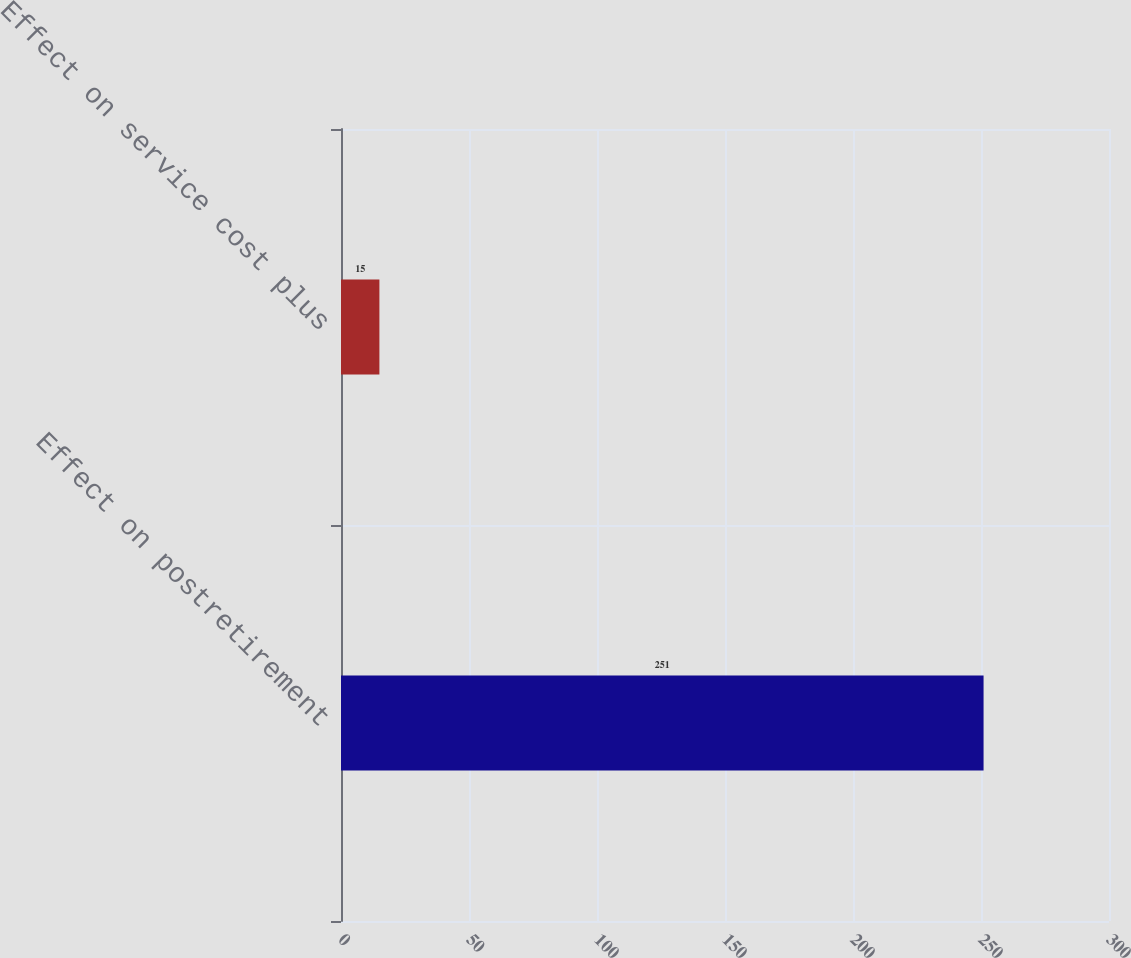<chart> <loc_0><loc_0><loc_500><loc_500><bar_chart><fcel>Effect on postretirement<fcel>Effect on service cost plus<nl><fcel>251<fcel>15<nl></chart> 